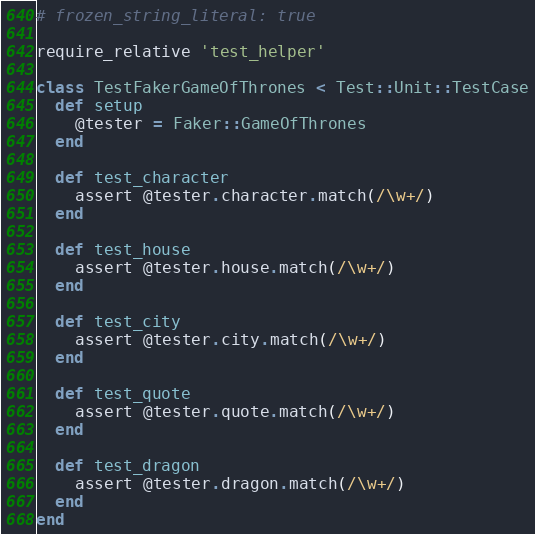Convert code to text. <code><loc_0><loc_0><loc_500><loc_500><_Ruby_># frozen_string_literal: true

require_relative 'test_helper'

class TestFakerGameOfThrones < Test::Unit::TestCase
  def setup
    @tester = Faker::GameOfThrones
  end

  def test_character
    assert @tester.character.match(/\w+/)
  end

  def test_house
    assert @tester.house.match(/\w+/)
  end

  def test_city
    assert @tester.city.match(/\w+/)
  end

  def test_quote
    assert @tester.quote.match(/\w+/)
  end

  def test_dragon
    assert @tester.dragon.match(/\w+/)
  end
end
</code> 